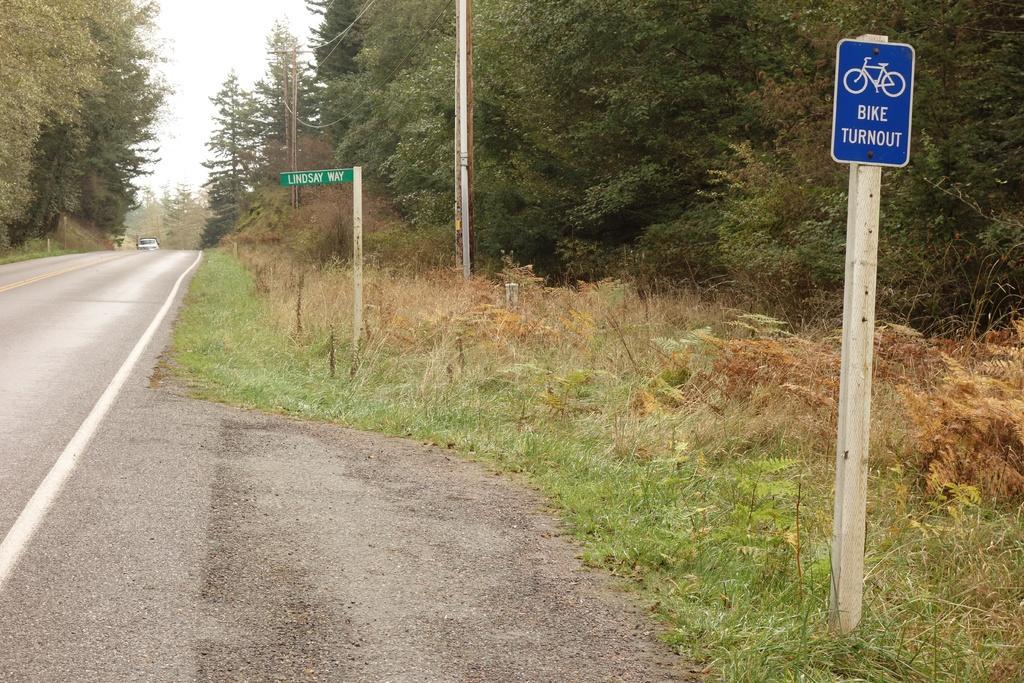Provide a one-sentence caption for the provided image. A bike turnout sign is beside a road. 